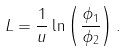<formula> <loc_0><loc_0><loc_500><loc_500>L = \frac { 1 } { u } \ln \left ( \frac { \phi _ { 1 } } { \phi _ { 2 } } \right ) .</formula> 